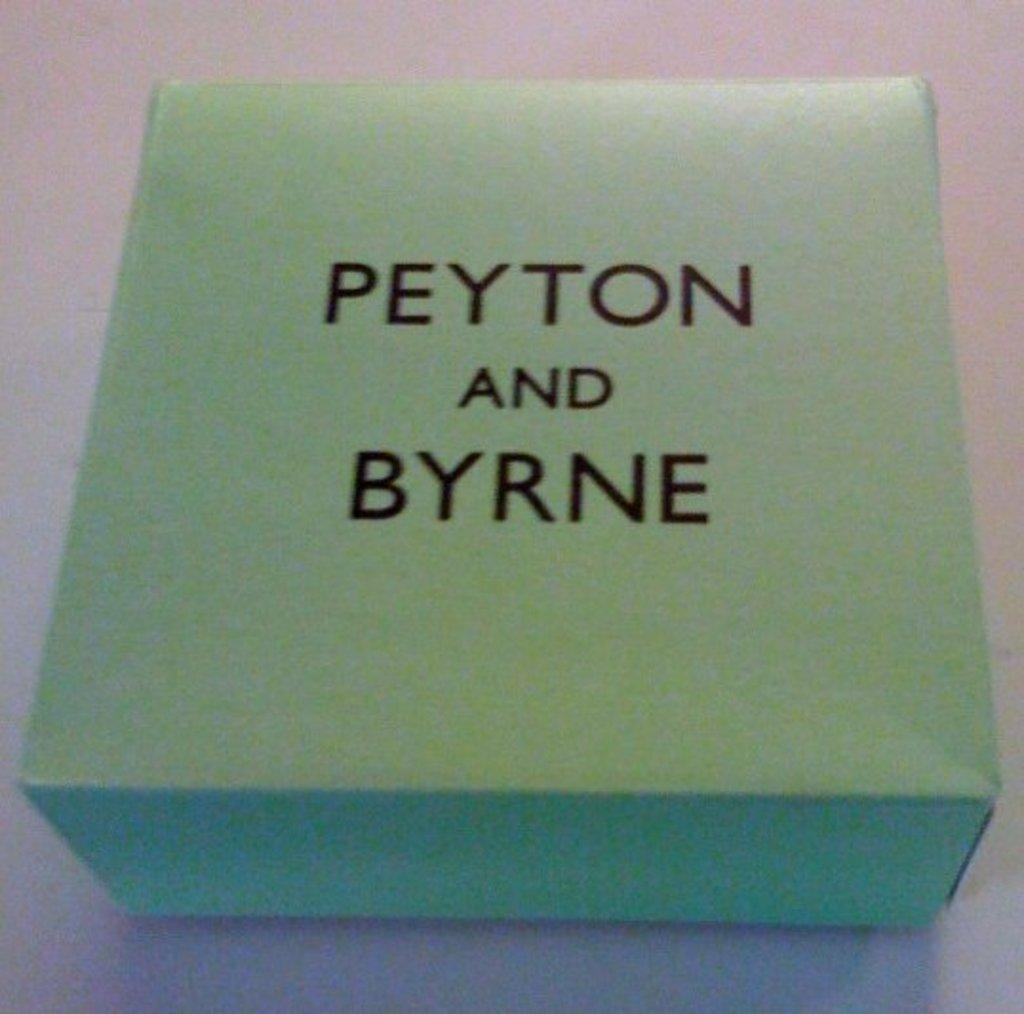<image>
Relay a brief, clear account of the picture shown. the name Peyton is written on a blue background 